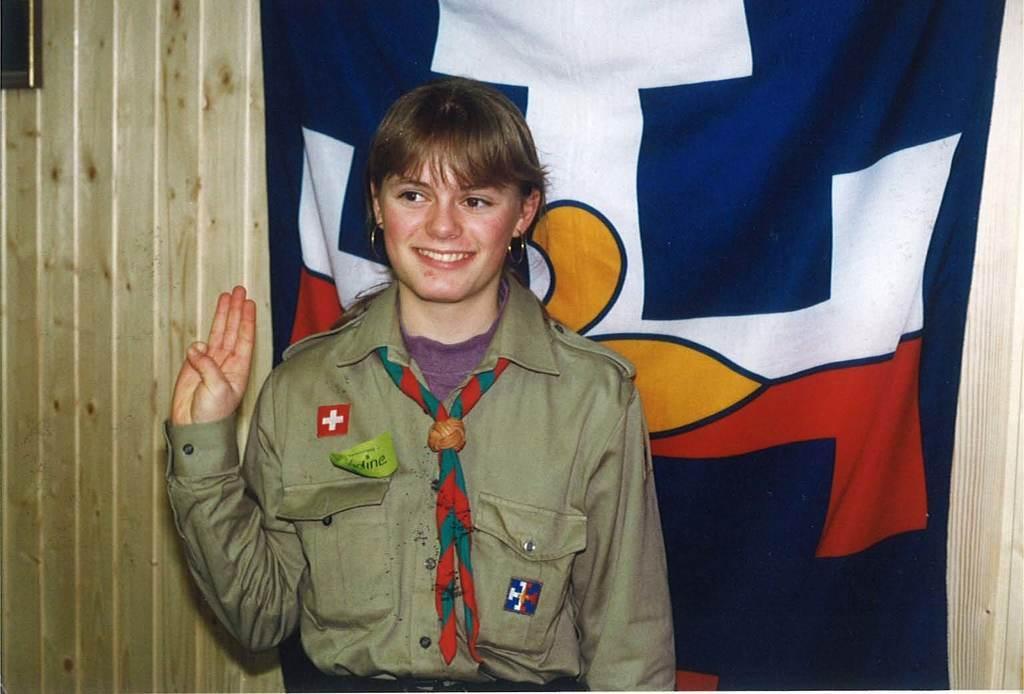In one or two sentences, can you explain what this image depicts? In the center of the image there is a lady wearing a uniform. In the background of the image there is a wall. There is a blue color cloth. 